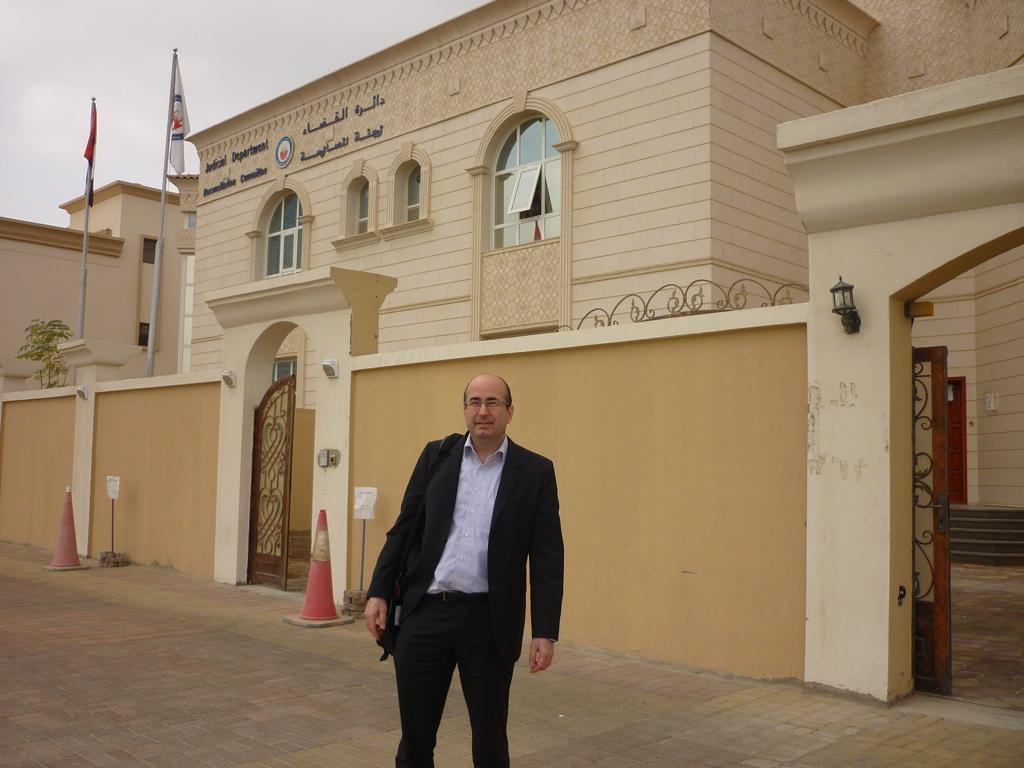In one or two sentences, can you explain what this image depicts? This image is taken outdoors. At the top of the image there is the sky with clouds. At the bottom of the image there is a floor. In the background there is a building with walls, windows, a door, gates and roofs. There is a text on the wall. There are two flags and there are two safety cones on the floor. In the middle of the image a man is standing on the floor. 